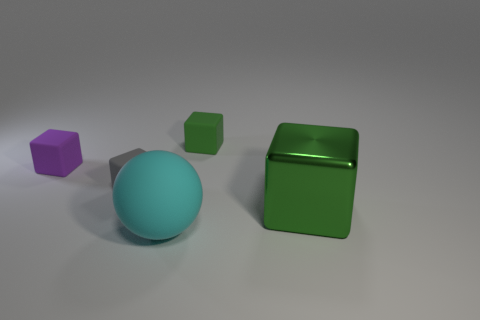Are there any other things that are the same material as the large green block?
Your answer should be compact. No. Is there anything else that is the same shape as the big cyan matte object?
Offer a very short reply. No. Is the size of the green metallic block the same as the purple object?
Provide a short and direct response. No. How many other things are there of the same size as the green metallic object?
Offer a terse response. 1. How many objects are either large green metal things that are in front of the green rubber cube or large green cubes on the right side of the tiny purple cube?
Offer a very short reply. 1. What shape is the purple thing that is the same size as the gray block?
Provide a short and direct response. Cube. There is a sphere that is the same material as the small purple block; what is its size?
Your answer should be compact. Large. Does the big green thing have the same shape as the small purple rubber thing?
Keep it short and to the point. Yes. There is a shiny cube that is the same size as the cyan rubber object; what color is it?
Ensure brevity in your answer.  Green. There is a green metal thing that is the same shape as the gray object; what size is it?
Ensure brevity in your answer.  Large. 